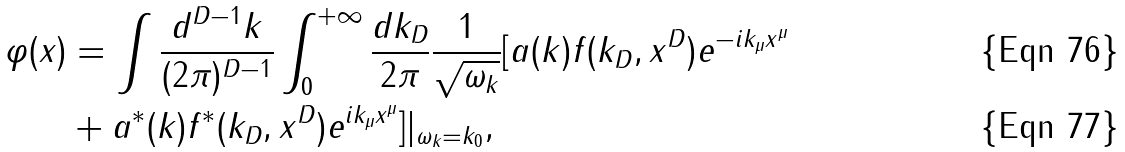<formula> <loc_0><loc_0><loc_500><loc_500>\varphi ( x ) & = \int \frac { d ^ { D - 1 } k } { ( 2 \pi ) ^ { D - 1 } } \int _ { 0 } ^ { + \infty } \frac { d k _ { D } } { 2 \pi } \frac { 1 } { \sqrt { \omega _ { k } } } [ a ( k ) f ( k _ { D } , x ^ { D } ) e ^ { - i k _ { \mu } x ^ { \mu } } \\ & + a ^ { \ast } ( k ) f ^ { \ast } ( k _ { D } , x ^ { D } ) e ^ { i k _ { \mu } x ^ { \mu } } ] | _ { \omega _ { k } = k _ { 0 } } ,</formula> 